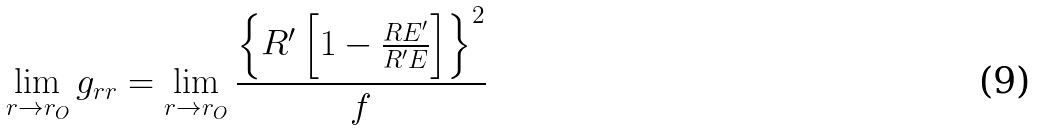<formula> <loc_0><loc_0><loc_500><loc_500>\lim _ { r \to r _ { O } } g _ { r r } = \lim _ { r \to r _ { O } } \frac { \left \{ R ^ { \prime } \left [ 1 - \frac { R E ^ { \prime } } { R ^ { \prime } E } \right ] \right \} ^ { 2 } } { f }</formula> 